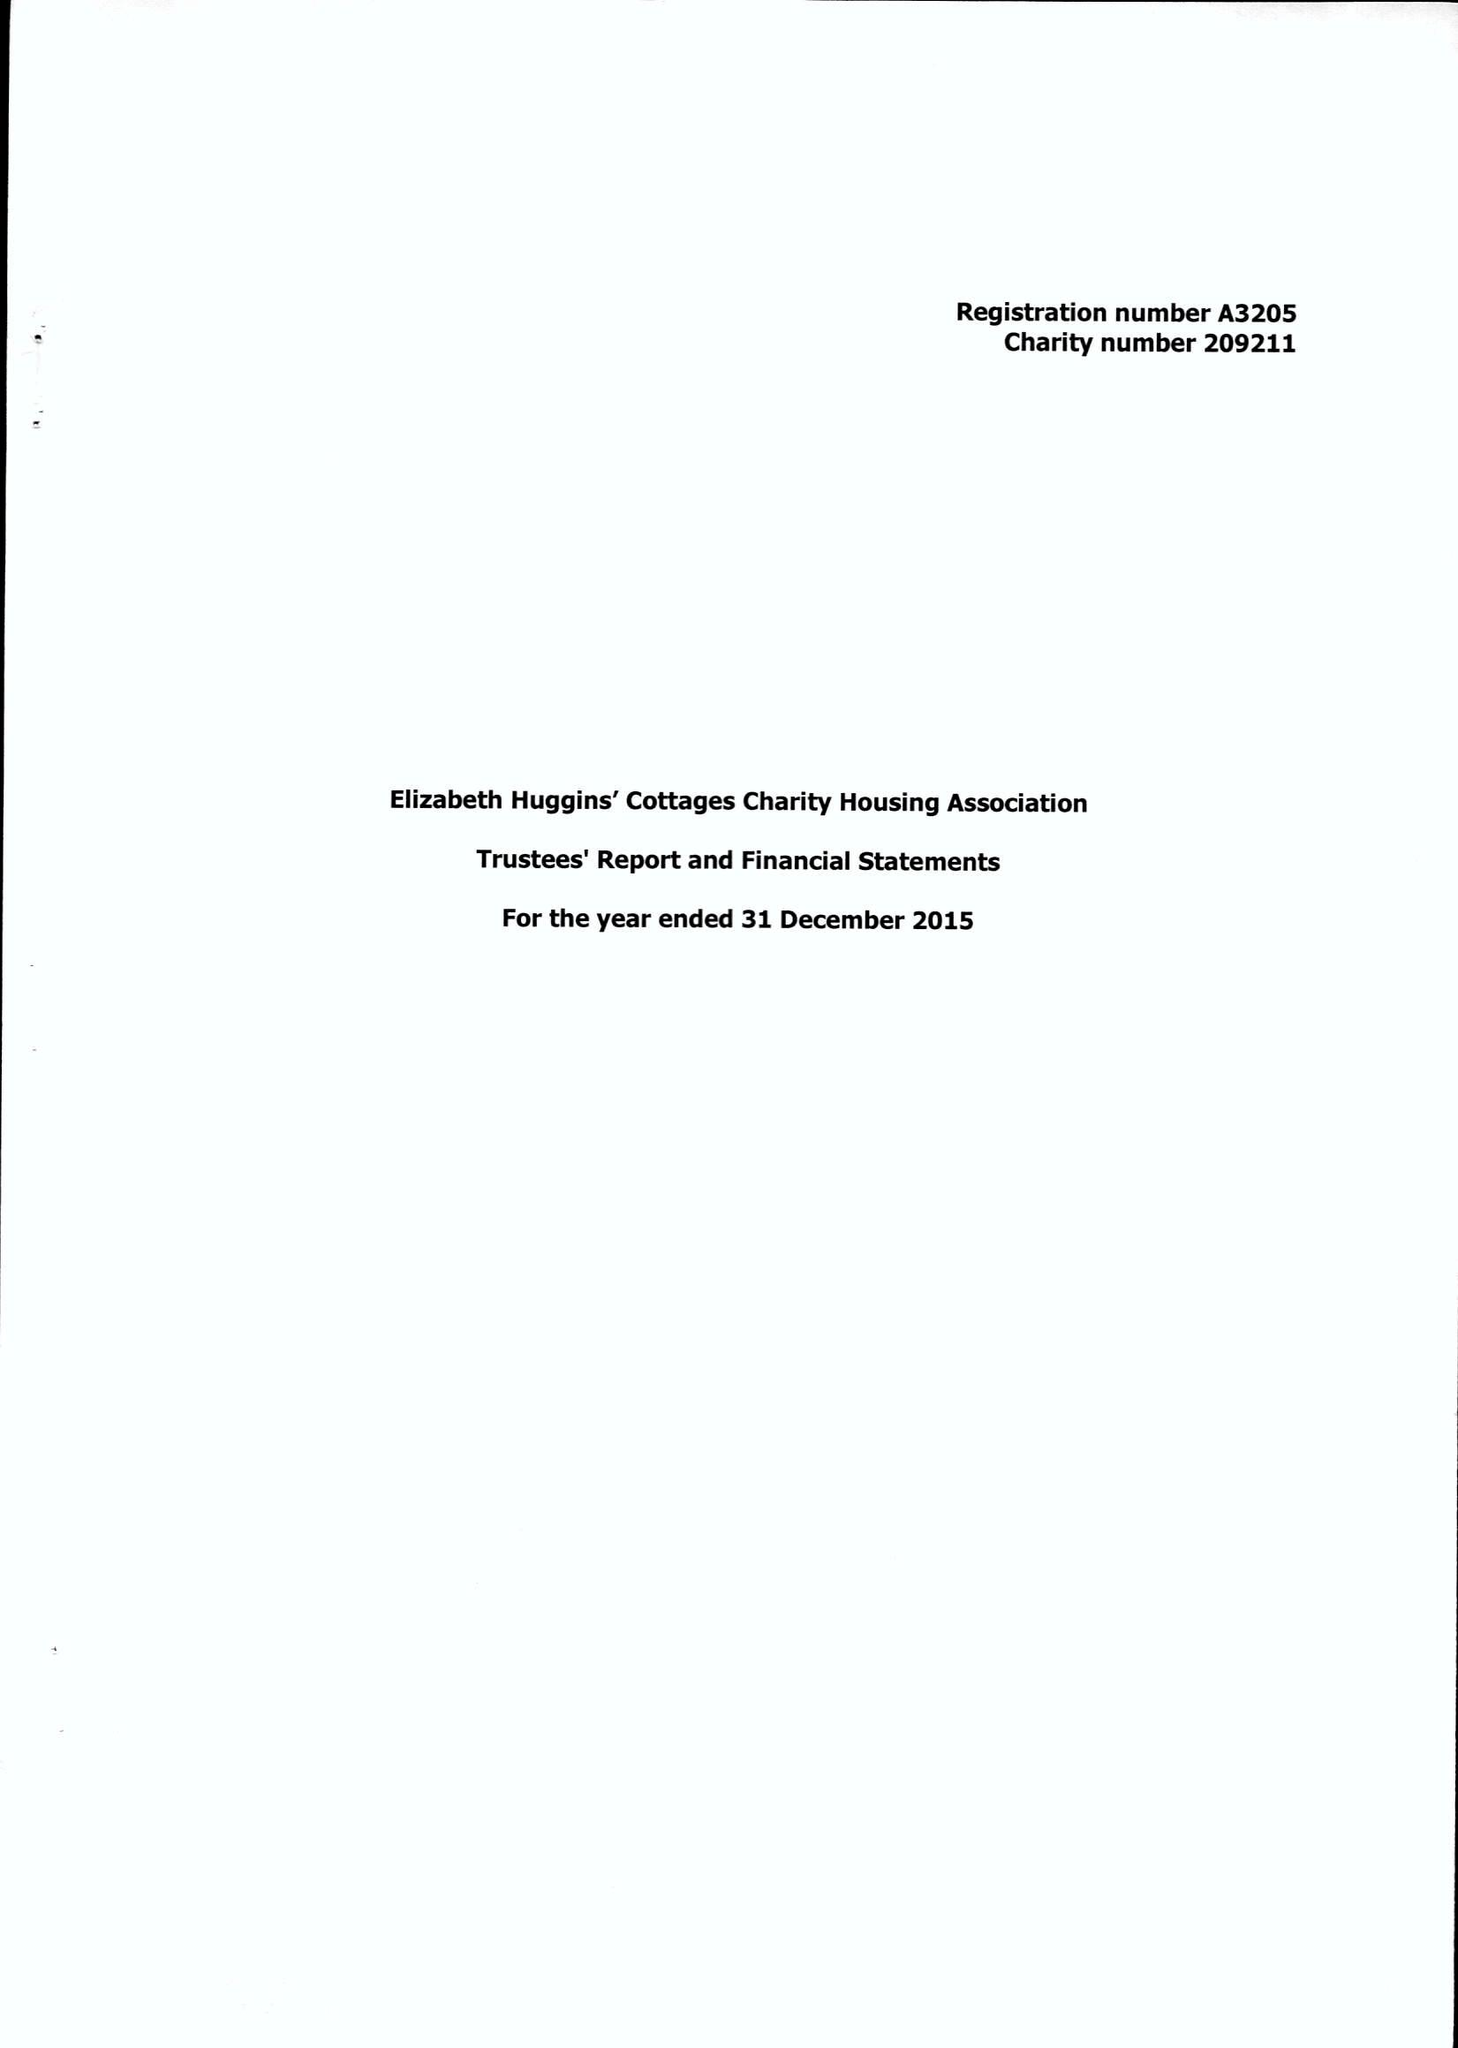What is the value for the charity_number?
Answer the question using a single word or phrase. 209211 